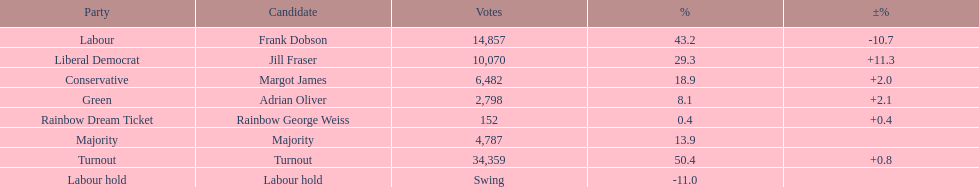I'm looking to parse the entire table for insights. Could you assist me with that? {'header': ['Party', 'Candidate', 'Votes', '%', '±%'], 'rows': [['Labour', 'Frank Dobson', '14,857', '43.2', '-10.7'], ['Liberal Democrat', 'Jill Fraser', '10,070', '29.3', '+11.3'], ['Conservative', 'Margot James', '6,482', '18.9', '+2.0'], ['Green', 'Adrian Oliver', '2,798', '8.1', '+2.1'], ['Rainbow Dream Ticket', 'Rainbow George Weiss', '152', '0.4', '+0.4'], ['Majority', 'Majority', '4,787', '13.9', ''], ['Turnout', 'Turnout', '34,359', '50.4', '+0.8'], ['Labour hold', 'Labour hold', 'Swing', '-11.0', '']]} What was the total number of votes received by the conservative party and the rainbow dream ticket party? 6634. 